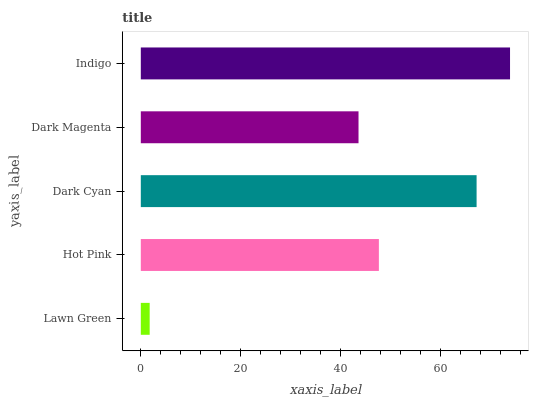Is Lawn Green the minimum?
Answer yes or no. Yes. Is Indigo the maximum?
Answer yes or no. Yes. Is Hot Pink the minimum?
Answer yes or no. No. Is Hot Pink the maximum?
Answer yes or no. No. Is Hot Pink greater than Lawn Green?
Answer yes or no. Yes. Is Lawn Green less than Hot Pink?
Answer yes or no. Yes. Is Lawn Green greater than Hot Pink?
Answer yes or no. No. Is Hot Pink less than Lawn Green?
Answer yes or no. No. Is Hot Pink the high median?
Answer yes or no. Yes. Is Hot Pink the low median?
Answer yes or no. Yes. Is Dark Cyan the high median?
Answer yes or no. No. Is Indigo the low median?
Answer yes or no. No. 